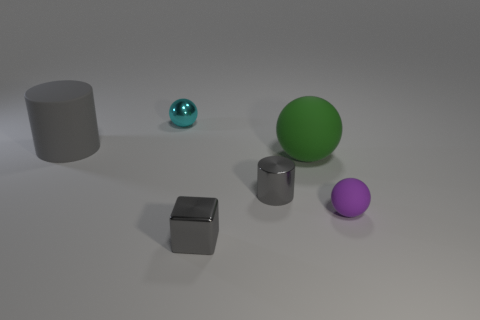Subtract all metallic spheres. How many spheres are left? 2 Add 1 metallic things. How many objects exist? 7 Subtract all green spheres. How many spheres are left? 2 Subtract all cylinders. How many objects are left? 4 Subtract 2 balls. How many balls are left? 1 Subtract all brown spheres. Subtract all cyan cubes. How many spheres are left? 3 Subtract all small purple matte spheres. Subtract all big gray cylinders. How many objects are left? 4 Add 5 cyan shiny spheres. How many cyan shiny spheres are left? 6 Add 5 small cyan balls. How many small cyan balls exist? 6 Subtract 1 gray cylinders. How many objects are left? 5 